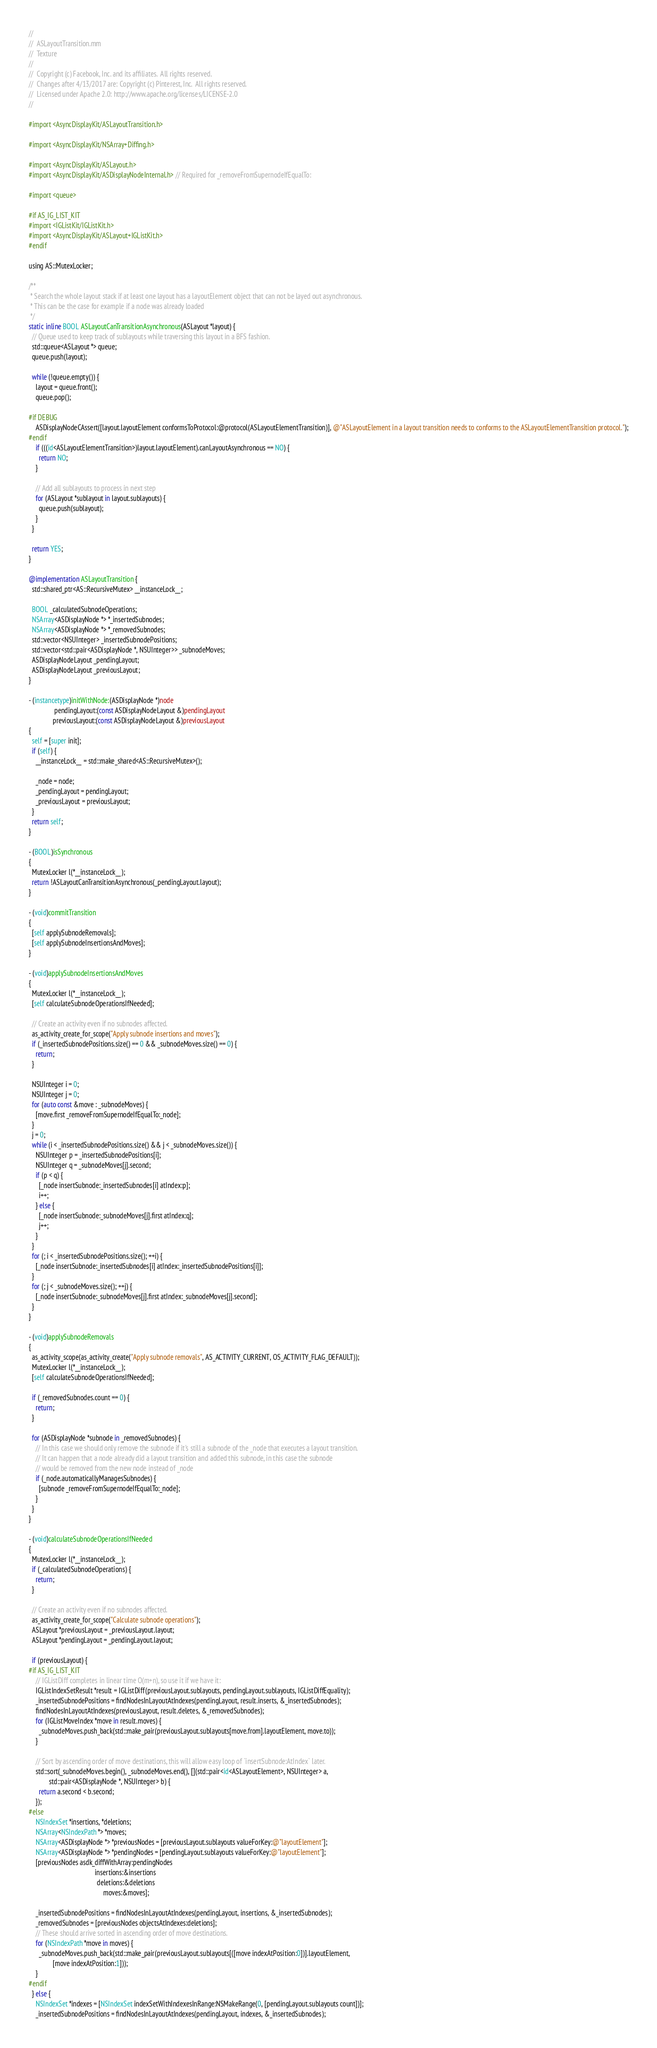Convert code to text. <code><loc_0><loc_0><loc_500><loc_500><_ObjectiveC_>//
//  ASLayoutTransition.mm
//  Texture
//
//  Copyright (c) Facebook, Inc. and its affiliates.  All rights reserved.
//  Changes after 4/13/2017 are: Copyright (c) Pinterest, Inc.  All rights reserved.
//  Licensed under Apache 2.0: http://www.apache.org/licenses/LICENSE-2.0
//

#import <AsyncDisplayKit/ASLayoutTransition.h>

#import <AsyncDisplayKit/NSArray+Diffing.h>

#import <AsyncDisplayKit/ASLayout.h>
#import <AsyncDisplayKit/ASDisplayNodeInternal.h> // Required for _removeFromSupernodeIfEqualTo:

#import <queue>

#if AS_IG_LIST_KIT
#import <IGListKit/IGListKit.h>
#import <AsyncDisplayKit/ASLayout+IGListKit.h>
#endif

using AS::MutexLocker;

/**
 * Search the whole layout stack if at least one layout has a layoutElement object that can not be layed out asynchronous.
 * This can be the case for example if a node was already loaded
 */
static inline BOOL ASLayoutCanTransitionAsynchronous(ASLayout *layout) {
  // Queue used to keep track of sublayouts while traversing this layout in a BFS fashion.
  std::queue<ASLayout *> queue;
  queue.push(layout);
  
  while (!queue.empty()) {
    layout = queue.front();
    queue.pop();
    
#if DEBUG
    ASDisplayNodeCAssert([layout.layoutElement conformsToProtocol:@protocol(ASLayoutElementTransition)], @"ASLayoutElement in a layout transition needs to conforms to the ASLayoutElementTransition protocol.");
#endif
    if (((id<ASLayoutElementTransition>)layout.layoutElement).canLayoutAsynchronous == NO) {
      return NO;
    }
    
    // Add all sublayouts to process in next step
    for (ASLayout *sublayout in layout.sublayouts) {
      queue.push(sublayout);
    }
  }
  
  return YES;
}

@implementation ASLayoutTransition {
  std::shared_ptr<AS::RecursiveMutex> __instanceLock__;
  
  BOOL _calculatedSubnodeOperations;
  NSArray<ASDisplayNode *> *_insertedSubnodes;
  NSArray<ASDisplayNode *> *_removedSubnodes;
  std::vector<NSUInteger> _insertedSubnodePositions;
  std::vector<std::pair<ASDisplayNode *, NSUInteger>> _subnodeMoves;
  ASDisplayNodeLayout _pendingLayout;
  ASDisplayNodeLayout _previousLayout;
}

- (instancetype)initWithNode:(ASDisplayNode *)node
               pendingLayout:(const ASDisplayNodeLayout &)pendingLayout
              previousLayout:(const ASDisplayNodeLayout &)previousLayout
{
  self = [super init];
  if (self) {
    __instanceLock__ = std::make_shared<AS::RecursiveMutex>();
      
    _node = node;
    _pendingLayout = pendingLayout;
    _previousLayout = previousLayout;
  }
  return self;
}

- (BOOL)isSynchronous
{
  MutexLocker l(*__instanceLock__);
  return !ASLayoutCanTransitionAsynchronous(_pendingLayout.layout);
}

- (void)commitTransition
{
  [self applySubnodeRemovals];
  [self applySubnodeInsertionsAndMoves];
}

- (void)applySubnodeInsertionsAndMoves
{
  MutexLocker l(*__instanceLock__);
  [self calculateSubnodeOperationsIfNeeded];
  
  // Create an activity even if no subnodes affected.
  as_activity_create_for_scope("Apply subnode insertions and moves");
  if (_insertedSubnodePositions.size() == 0 && _subnodeMoves.size() == 0) {
    return;
  }

  NSUInteger i = 0;
  NSUInteger j = 0;
  for (auto const &move : _subnodeMoves) {
    [move.first _removeFromSupernodeIfEqualTo:_node];
  }
  j = 0;
  while (i < _insertedSubnodePositions.size() && j < _subnodeMoves.size()) {
    NSUInteger p = _insertedSubnodePositions[i];
    NSUInteger q = _subnodeMoves[j].second;
    if (p < q) {
      [_node insertSubnode:_insertedSubnodes[i] atIndex:p];
      i++;
    } else {
      [_node insertSubnode:_subnodeMoves[j].first atIndex:q];
      j++;
    }
  }
  for (; i < _insertedSubnodePositions.size(); ++i) {
    [_node insertSubnode:_insertedSubnodes[i] atIndex:_insertedSubnodePositions[i]];
  }
  for (; j < _subnodeMoves.size(); ++j) {
    [_node insertSubnode:_subnodeMoves[j].first atIndex:_subnodeMoves[j].second];
  }
}

- (void)applySubnodeRemovals
{
  as_activity_scope(as_activity_create("Apply subnode removals", AS_ACTIVITY_CURRENT, OS_ACTIVITY_FLAG_DEFAULT));
  MutexLocker l(*__instanceLock__);
  [self calculateSubnodeOperationsIfNeeded];

  if (_removedSubnodes.count == 0) {
    return;
  }

  for (ASDisplayNode *subnode in _removedSubnodes) {
    // In this case we should only remove the subnode if it's still a subnode of the _node that executes a layout transition.
    // It can happen that a node already did a layout transition and added this subnode, in this case the subnode
    // would be removed from the new node instead of _node
    if (_node.automaticallyManagesSubnodes) {
      [subnode _removeFromSupernodeIfEqualTo:_node];
    }
  }
}

- (void)calculateSubnodeOperationsIfNeeded
{
  MutexLocker l(*__instanceLock__);
  if (_calculatedSubnodeOperations) {
    return;
  }
  
  // Create an activity even if no subnodes affected.
  as_activity_create_for_scope("Calculate subnode operations");
  ASLayout *previousLayout = _previousLayout.layout;
  ASLayout *pendingLayout = _pendingLayout.layout;

  if (previousLayout) {
#if AS_IG_LIST_KIT
    // IGListDiff completes in linear time O(m+n), so use it if we have it:
    IGListIndexSetResult *result = IGListDiff(previousLayout.sublayouts, pendingLayout.sublayouts, IGListDiffEquality);
    _insertedSubnodePositions = findNodesInLayoutAtIndexes(pendingLayout, result.inserts, &_insertedSubnodes);
    findNodesInLayoutAtIndexes(previousLayout, result.deletes, &_removedSubnodes);
    for (IGListMoveIndex *move in result.moves) {
      _subnodeMoves.push_back(std::make_pair(previousLayout.sublayouts[move.from].layoutElement, move.to));
    }

    // Sort by ascending order of move destinations, this will allow easy loop of `insertSubnode:AtIndex` later.
    std::sort(_subnodeMoves.begin(), _subnodeMoves.end(), [](std::pair<id<ASLayoutElement>, NSUInteger> a,
            std::pair<ASDisplayNode *, NSUInteger> b) {
      return a.second < b.second;
    });
#else
    NSIndexSet *insertions, *deletions;
    NSArray<NSIndexPath *> *moves;
    NSArray<ASDisplayNode *> *previousNodes = [previousLayout.sublayouts valueForKey:@"layoutElement"];
    NSArray<ASDisplayNode *> *pendingNodes = [pendingLayout.sublayouts valueForKey:@"layoutElement"];
    [previousNodes asdk_diffWithArray:pendingNodes
                                       insertions:&insertions
                                        deletions:&deletions
                                            moves:&moves];

    _insertedSubnodePositions = findNodesInLayoutAtIndexes(pendingLayout, insertions, &_insertedSubnodes);
    _removedSubnodes = [previousNodes objectsAtIndexes:deletions];
    // These should arrive sorted in ascending order of move destinations.
    for (NSIndexPath *move in moves) {
      _subnodeMoves.push_back(std::make_pair(previousLayout.sublayouts[([move indexAtPosition:0])].layoutElement,
              [move indexAtPosition:1]));
    }
#endif
  } else {
    NSIndexSet *indexes = [NSIndexSet indexSetWithIndexesInRange:NSMakeRange(0, [pendingLayout.sublayouts count])];
    _insertedSubnodePositions = findNodesInLayoutAtIndexes(pendingLayout, indexes, &_insertedSubnodes);</code> 